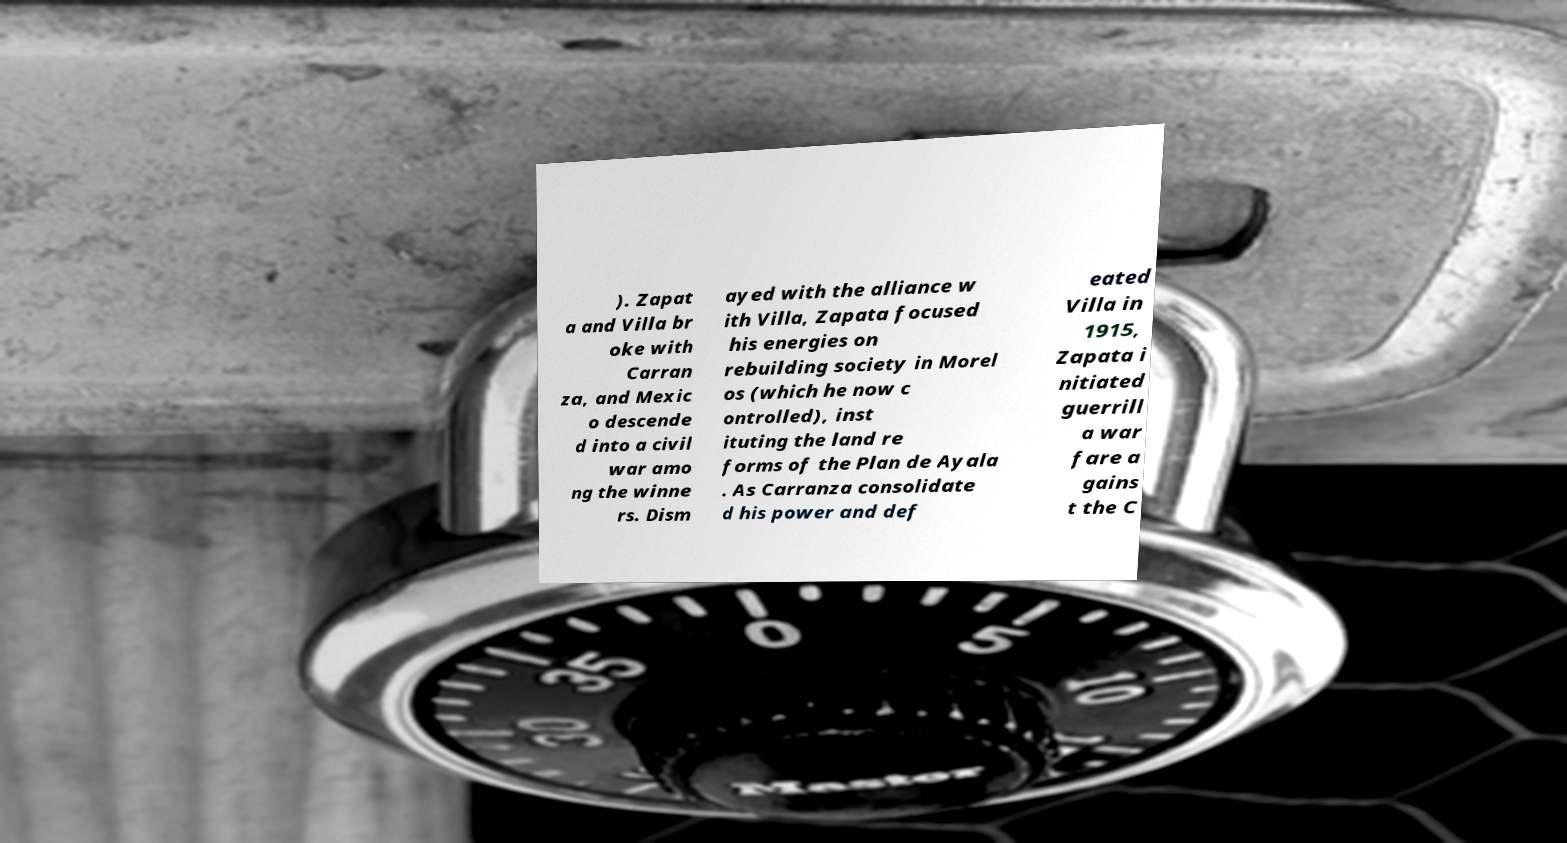I need the written content from this picture converted into text. Can you do that? ). Zapat a and Villa br oke with Carran za, and Mexic o descende d into a civil war amo ng the winne rs. Dism ayed with the alliance w ith Villa, Zapata focused his energies on rebuilding society in Morel os (which he now c ontrolled), inst ituting the land re forms of the Plan de Ayala . As Carranza consolidate d his power and def eated Villa in 1915, Zapata i nitiated guerrill a war fare a gains t the C 